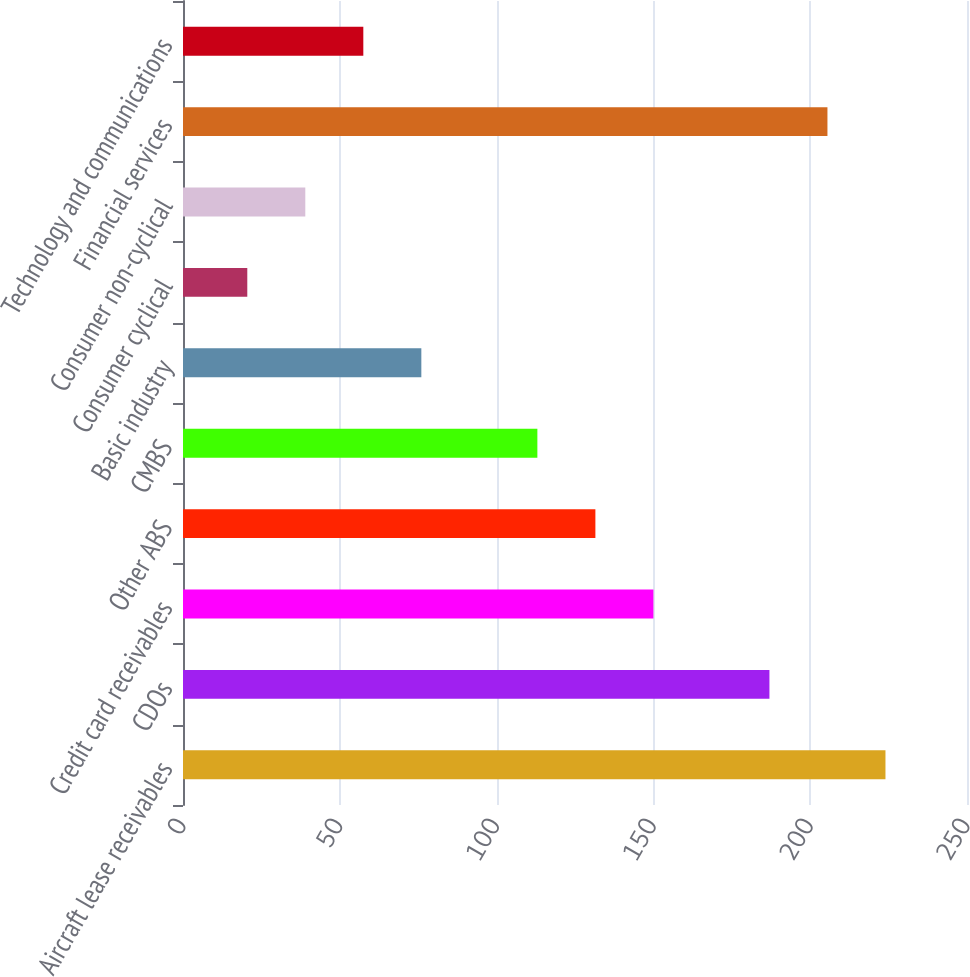Convert chart. <chart><loc_0><loc_0><loc_500><loc_500><bar_chart><fcel>Aircraft lease receivables<fcel>CDOs<fcel>Credit card receivables<fcel>Other ABS<fcel>CMBS<fcel>Basic industry<fcel>Consumer cyclical<fcel>Consumer non-cyclical<fcel>Financial services<fcel>Technology and communications<nl><fcel>224<fcel>187<fcel>150<fcel>131.5<fcel>113<fcel>76<fcel>20.5<fcel>39<fcel>205.5<fcel>57.5<nl></chart> 